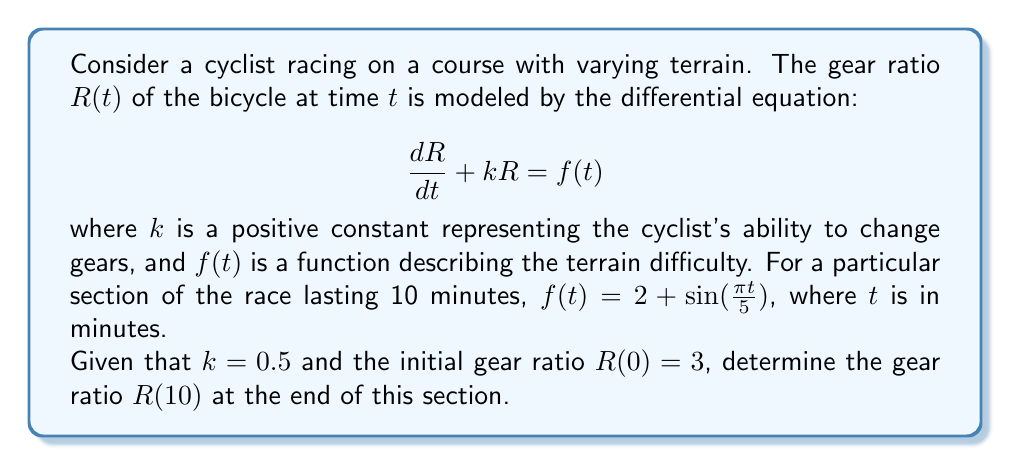Help me with this question. To solve this problem, we need to use the method for solving first-order linear differential equations. The general form of the solution is:

$$R(t) = e^{-kt}\left(C + \int e^{kt}f(t)dt\right)$$

where $C$ is a constant determined by the initial condition.

1) First, we calculate $\int e^{kt}f(t)dt$:

   $$\begin{align}
   \int e^{kt}f(t)dt &= \int e^{0.5t}(2 + \sin(\frac{\pi t}{5}))dt \\
   &= \int 2e^{0.5t}dt + \int e^{0.5t}\sin(\frac{\pi t}{5})dt
   \end{align}$$

2) The first integral is straightforward:

   $$\int 2e^{0.5t}dt = 4e^{0.5t} + C_1$$

3) For the second integral, we use integration by parts twice:

   $$\begin{align}
   \int e^{0.5t}\sin(\frac{\pi t}{5})dt &= \frac{5}{\pi}\left(e^{0.5t}\sin(\frac{\pi t}{5}) - 0.5\int e^{0.5t}\cos(\frac{\pi t}{5})dt\right) \\
   &= \frac{5}{\pi}e^{0.5t}\sin(\frac{\pi t}{5}) - \frac{2.5}{\pi}\left(e^{0.5t}\cos(\frac{\pi t}{5}) + 0.5\int e^{0.5t}\sin(\frac{\pi t}{5})dt\right)
   \end{align}$$

4) Solving for the integral:

   $$\int e^{0.5t}\sin(\frac{\pi t}{5})dt = \frac{10e^{0.5t}}{0.25 + (\frac{\pi}{5})^2}\left(0.5\sin(\frac{\pi t}{5}) - \frac{\pi}{5}\cos(\frac{\pi t}{5})\right) + C_2$$

5) Combining the results:

   $$R(t) = e^{-0.5t}\left(C + 4e^{0.5t} + \frac{10e^{0.5t}}{0.25 + (\frac{\pi}{5})^2}\left(0.5\sin(\frac{\pi t}{5}) - \frac{\pi}{5}\cos(\frac{\pi t}{5})\right)\right)$$

6) Using the initial condition $R(0) = 3$:

   $$3 = C + 4 - \frac{2\pi}{0.25 + (\frac{\pi}{5})^2}$$

   $$C = 3 - 4 + \frac{2\pi}{0.25 + (\frac{\pi}{5})^2} \approx 1.7384$$

7) Finally, we can calculate $R(10)$:

   $$\begin{align}
   R(10) &= e^{-5}\left(1.7384 + 4e^5 + \frac{10e^5}{0.25 + (\frac{\pi}{5})^2}\left(0.5\sin(2\pi) - \frac{\pi}{5}\cos(2\pi)\right)\right) \\
   &\approx 4.0027
   \end{align}$$
Answer: The gear ratio at the end of the 10-minute section is approximately 4.0027. 